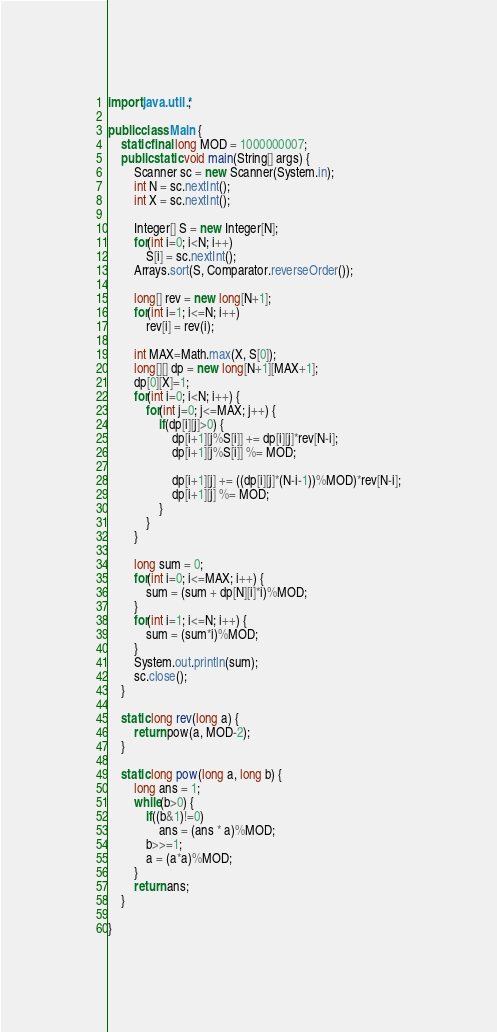<code> <loc_0><loc_0><loc_500><loc_500><_Java_>import java.util.*;

public class Main {
	static final long MOD = 1000000007;
	public static void main(String[] args) {
		Scanner sc = new Scanner(System.in);
		int N = sc.nextInt();
		int X = sc.nextInt();
		
		Integer[] S = new Integer[N];
		for(int i=0; i<N; i++)
			S[i] = sc.nextInt();
		Arrays.sort(S, Comparator.reverseOrder());
		
		long[] rev = new long[N+1];
		for(int i=1; i<=N; i++)
			rev[i] = rev(i);
		
		int MAX=Math.max(X, S[0]);
		long[][] dp = new long[N+1][MAX+1];
		dp[0][X]=1;
		for(int i=0; i<N; i++) {
			for(int j=0; j<=MAX; j++) {
				if(dp[i][j]>0) {
					dp[i+1][j%S[i]] += dp[i][j]*rev[N-i];
					dp[i+1][j%S[i]] %= MOD;
					
					dp[i+1][j] += ((dp[i][j]*(N-i-1))%MOD)*rev[N-i];
					dp[i+1][j] %= MOD;
				}
			}
		}
		
		long sum = 0;
		for(int i=0; i<=MAX; i++) {
			sum = (sum + dp[N][i]*i)%MOD;
		}
		for(int i=1; i<=N; i++) {
			sum = (sum*i)%MOD;
		}
		System.out.println(sum);
		sc.close();
	}
	
	static long rev(long a) {
		return pow(a, MOD-2);
	}
	
	static long pow(long a, long b) {
		long ans = 1;
		while(b>0) {
			if((b&1)!=0)
				ans = (ans * a)%MOD;
			b>>=1;
			a = (a*a)%MOD;
		}
		return ans;
	}

}
</code> 